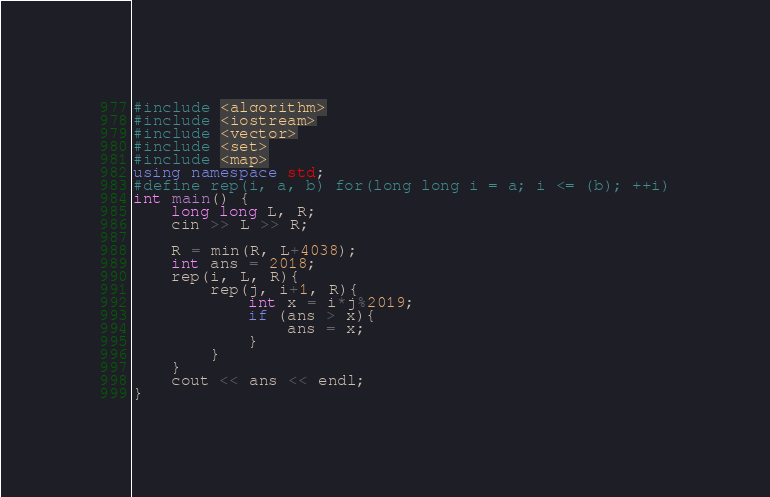Convert code to text. <code><loc_0><loc_0><loc_500><loc_500><_C++_>#include <algorithm>
#include <iostream>
#include <vector>
#include <set>
#include <map>
using namespace std;
#define rep(i, a, b) for(long long i = a; i <= (b); ++i)
int main() {
    long long L, R;
    cin >> L >> R;
    
    R = min(R, L+4038);
    int ans = 2018;
    rep(i, L, R){
        rep(j, i+1, R){
            int x = i*j%2019;
            if (ans > x){
                ans = x;
            }
        }
    }
    cout << ans << endl;
}
</code> 